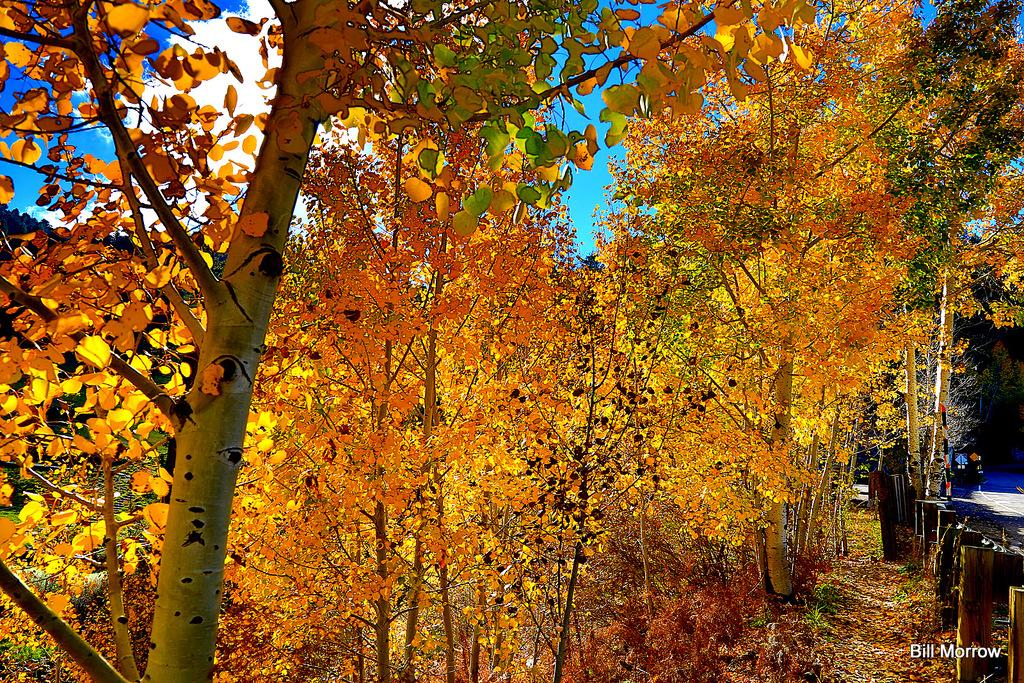What type of vegetation can be seen in the image? There are trees in the image. What is the color of the leaves on the trees? There are yellow-colored leaves in the image. What is one man-made feature visible in the image? There is a road in the image. What can be seen in the background of the image? Clouds and the sky are visible in the background of the image. Are there any shadows in the image? Yes, there are shadows in the image. Is there any text or logo visible in the image? Yes, there is a watermark in the image. What type of bead is used to create the yellow-colored leaves in the image? There are no beads present in the image; the yellow-colored leaves are part of the trees. What is the reason for the shadows in the image? The shadows in the image are caused by the presence of objects blocking the sunlight, but the specific reason for each shadow cannot be determined from the image alone. 